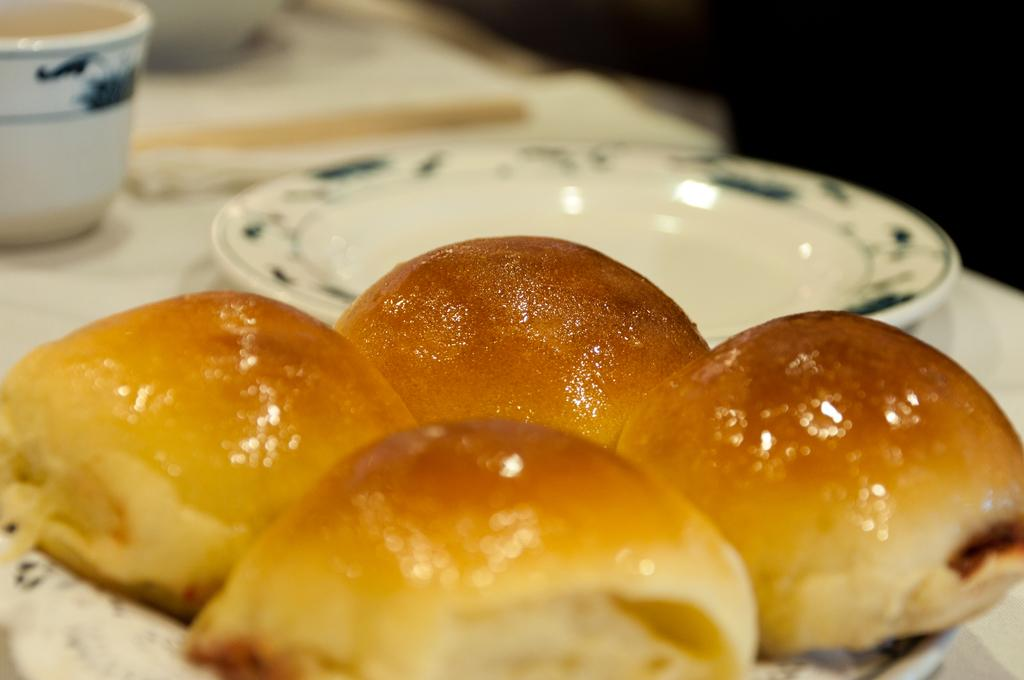How many breads are visible in the image? There are four breads in the image. What is the plate used for in the image? The plate is used to hold the breads in the image. What is the cup used for in the image? The cup is used to hold a beverage, but its contents are not visible in the image. What is the vessel used for in the image? The vessel is used to hold a liquid, but its contents are not visible in the image. Where are the objects located in the image? The objects are on a table in the image. Is there a carriage visible in the image? No, there is no carriage present in the image. 